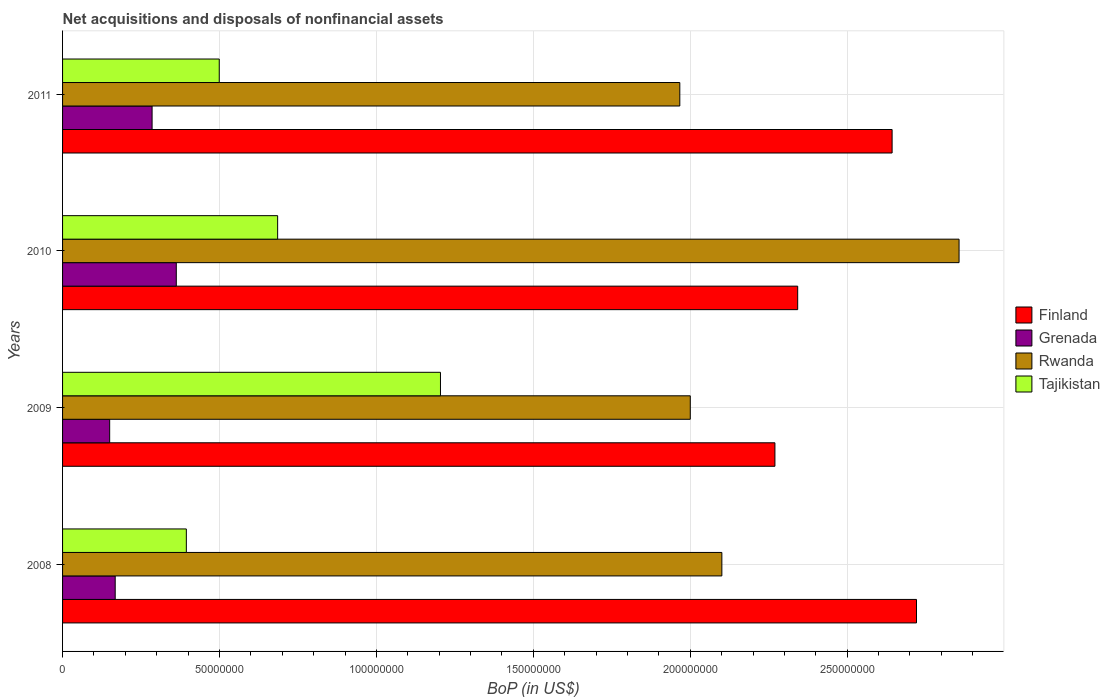Are the number of bars per tick equal to the number of legend labels?
Provide a succinct answer. Yes. Are the number of bars on each tick of the Y-axis equal?
Offer a terse response. Yes. In how many cases, is the number of bars for a given year not equal to the number of legend labels?
Your response must be concise. 0. What is the Balance of Payments in Finland in 2008?
Keep it short and to the point. 2.72e+08. Across all years, what is the maximum Balance of Payments in Tajikistan?
Ensure brevity in your answer.  1.20e+08. Across all years, what is the minimum Balance of Payments in Tajikistan?
Offer a terse response. 3.94e+07. What is the total Balance of Payments in Finland in the graph?
Your response must be concise. 9.98e+08. What is the difference between the Balance of Payments in Grenada in 2008 and that in 2009?
Offer a terse response. 1.76e+06. What is the difference between the Balance of Payments in Finland in 2010 and the Balance of Payments in Tajikistan in 2009?
Offer a very short reply. 1.14e+08. What is the average Balance of Payments in Grenada per year?
Your answer should be compact. 2.41e+07. In the year 2010, what is the difference between the Balance of Payments in Grenada and Balance of Payments in Finland?
Keep it short and to the point. -1.98e+08. In how many years, is the Balance of Payments in Rwanda greater than 220000000 US$?
Your answer should be compact. 1. What is the ratio of the Balance of Payments in Rwanda in 2010 to that in 2011?
Your answer should be compact. 1.45. Is the Balance of Payments in Finland in 2009 less than that in 2011?
Your response must be concise. Yes. Is the difference between the Balance of Payments in Grenada in 2010 and 2011 greater than the difference between the Balance of Payments in Finland in 2010 and 2011?
Give a very brief answer. Yes. What is the difference between the highest and the second highest Balance of Payments in Finland?
Your answer should be very brief. 7.77e+06. What is the difference between the highest and the lowest Balance of Payments in Rwanda?
Ensure brevity in your answer.  8.90e+07. In how many years, is the Balance of Payments in Tajikistan greater than the average Balance of Payments in Tajikistan taken over all years?
Ensure brevity in your answer.  1. What does the 1st bar from the top in 2010 represents?
Provide a short and direct response. Tajikistan. What does the 1st bar from the bottom in 2009 represents?
Keep it short and to the point. Finland. Is it the case that in every year, the sum of the Balance of Payments in Finland and Balance of Payments in Grenada is greater than the Balance of Payments in Tajikistan?
Your answer should be very brief. Yes. How many years are there in the graph?
Your response must be concise. 4. What is the difference between two consecutive major ticks on the X-axis?
Your answer should be compact. 5.00e+07. Are the values on the major ticks of X-axis written in scientific E-notation?
Your response must be concise. No. Where does the legend appear in the graph?
Make the answer very short. Center right. How many legend labels are there?
Provide a succinct answer. 4. What is the title of the graph?
Make the answer very short. Net acquisitions and disposals of nonfinancial assets. What is the label or title of the X-axis?
Provide a succinct answer. BoP (in US$). What is the label or title of the Y-axis?
Your answer should be very brief. Years. What is the BoP (in US$) of Finland in 2008?
Provide a succinct answer. 2.72e+08. What is the BoP (in US$) in Grenada in 2008?
Make the answer very short. 1.68e+07. What is the BoP (in US$) of Rwanda in 2008?
Keep it short and to the point. 2.10e+08. What is the BoP (in US$) in Tajikistan in 2008?
Your answer should be compact. 3.94e+07. What is the BoP (in US$) of Finland in 2009?
Give a very brief answer. 2.27e+08. What is the BoP (in US$) in Grenada in 2009?
Ensure brevity in your answer.  1.50e+07. What is the BoP (in US$) in Rwanda in 2009?
Ensure brevity in your answer.  2.00e+08. What is the BoP (in US$) in Tajikistan in 2009?
Ensure brevity in your answer.  1.20e+08. What is the BoP (in US$) of Finland in 2010?
Your answer should be compact. 2.34e+08. What is the BoP (in US$) in Grenada in 2010?
Keep it short and to the point. 3.62e+07. What is the BoP (in US$) of Rwanda in 2010?
Your answer should be very brief. 2.86e+08. What is the BoP (in US$) of Tajikistan in 2010?
Offer a very short reply. 6.85e+07. What is the BoP (in US$) of Finland in 2011?
Make the answer very short. 2.64e+08. What is the BoP (in US$) in Grenada in 2011?
Provide a succinct answer. 2.85e+07. What is the BoP (in US$) in Rwanda in 2011?
Provide a short and direct response. 1.97e+08. What is the BoP (in US$) in Tajikistan in 2011?
Keep it short and to the point. 4.99e+07. Across all years, what is the maximum BoP (in US$) in Finland?
Provide a succinct answer. 2.72e+08. Across all years, what is the maximum BoP (in US$) in Grenada?
Offer a very short reply. 3.62e+07. Across all years, what is the maximum BoP (in US$) of Rwanda?
Provide a succinct answer. 2.86e+08. Across all years, what is the maximum BoP (in US$) in Tajikistan?
Offer a terse response. 1.20e+08. Across all years, what is the minimum BoP (in US$) of Finland?
Keep it short and to the point. 2.27e+08. Across all years, what is the minimum BoP (in US$) in Grenada?
Your answer should be compact. 1.50e+07. Across all years, what is the minimum BoP (in US$) in Rwanda?
Offer a very short reply. 1.97e+08. Across all years, what is the minimum BoP (in US$) of Tajikistan?
Your response must be concise. 3.94e+07. What is the total BoP (in US$) of Finland in the graph?
Offer a very short reply. 9.98e+08. What is the total BoP (in US$) of Grenada in the graph?
Offer a very short reply. 9.65e+07. What is the total BoP (in US$) in Rwanda in the graph?
Keep it short and to the point. 8.92e+08. What is the total BoP (in US$) of Tajikistan in the graph?
Keep it short and to the point. 2.78e+08. What is the difference between the BoP (in US$) of Finland in 2008 and that in 2009?
Offer a very short reply. 4.51e+07. What is the difference between the BoP (in US$) of Grenada in 2008 and that in 2009?
Give a very brief answer. 1.76e+06. What is the difference between the BoP (in US$) in Rwanda in 2008 and that in 2009?
Offer a terse response. 1.01e+07. What is the difference between the BoP (in US$) in Tajikistan in 2008 and that in 2009?
Your response must be concise. -8.10e+07. What is the difference between the BoP (in US$) of Finland in 2008 and that in 2010?
Your response must be concise. 3.79e+07. What is the difference between the BoP (in US$) in Grenada in 2008 and that in 2010?
Your answer should be very brief. -1.95e+07. What is the difference between the BoP (in US$) in Rwanda in 2008 and that in 2010?
Offer a terse response. -7.56e+07. What is the difference between the BoP (in US$) of Tajikistan in 2008 and that in 2010?
Make the answer very short. -2.91e+07. What is the difference between the BoP (in US$) of Finland in 2008 and that in 2011?
Keep it short and to the point. 7.77e+06. What is the difference between the BoP (in US$) in Grenada in 2008 and that in 2011?
Give a very brief answer. -1.18e+07. What is the difference between the BoP (in US$) in Rwanda in 2008 and that in 2011?
Provide a short and direct response. 1.34e+07. What is the difference between the BoP (in US$) of Tajikistan in 2008 and that in 2011?
Your answer should be very brief. -1.05e+07. What is the difference between the BoP (in US$) of Finland in 2009 and that in 2010?
Offer a very short reply. -7.25e+06. What is the difference between the BoP (in US$) of Grenada in 2009 and that in 2010?
Your response must be concise. -2.12e+07. What is the difference between the BoP (in US$) in Rwanda in 2009 and that in 2010?
Ensure brevity in your answer.  -8.56e+07. What is the difference between the BoP (in US$) in Tajikistan in 2009 and that in 2010?
Your response must be concise. 5.19e+07. What is the difference between the BoP (in US$) in Finland in 2009 and that in 2011?
Make the answer very short. -3.73e+07. What is the difference between the BoP (in US$) in Grenada in 2009 and that in 2011?
Keep it short and to the point. -1.35e+07. What is the difference between the BoP (in US$) in Rwanda in 2009 and that in 2011?
Offer a very short reply. 3.34e+06. What is the difference between the BoP (in US$) in Tajikistan in 2009 and that in 2011?
Give a very brief answer. 7.05e+07. What is the difference between the BoP (in US$) in Finland in 2010 and that in 2011?
Your response must be concise. -3.01e+07. What is the difference between the BoP (in US$) of Grenada in 2010 and that in 2011?
Your answer should be very brief. 7.71e+06. What is the difference between the BoP (in US$) of Rwanda in 2010 and that in 2011?
Offer a very short reply. 8.90e+07. What is the difference between the BoP (in US$) of Tajikistan in 2010 and that in 2011?
Keep it short and to the point. 1.86e+07. What is the difference between the BoP (in US$) in Finland in 2008 and the BoP (in US$) in Grenada in 2009?
Provide a short and direct response. 2.57e+08. What is the difference between the BoP (in US$) in Finland in 2008 and the BoP (in US$) in Rwanda in 2009?
Your response must be concise. 7.21e+07. What is the difference between the BoP (in US$) in Finland in 2008 and the BoP (in US$) in Tajikistan in 2009?
Your answer should be compact. 1.52e+08. What is the difference between the BoP (in US$) in Grenada in 2008 and the BoP (in US$) in Rwanda in 2009?
Ensure brevity in your answer.  -1.83e+08. What is the difference between the BoP (in US$) in Grenada in 2008 and the BoP (in US$) in Tajikistan in 2009?
Keep it short and to the point. -1.04e+08. What is the difference between the BoP (in US$) of Rwanda in 2008 and the BoP (in US$) of Tajikistan in 2009?
Provide a short and direct response. 8.97e+07. What is the difference between the BoP (in US$) in Finland in 2008 and the BoP (in US$) in Grenada in 2010?
Give a very brief answer. 2.36e+08. What is the difference between the BoP (in US$) of Finland in 2008 and the BoP (in US$) of Rwanda in 2010?
Offer a very short reply. -1.36e+07. What is the difference between the BoP (in US$) of Finland in 2008 and the BoP (in US$) of Tajikistan in 2010?
Offer a terse response. 2.04e+08. What is the difference between the BoP (in US$) of Grenada in 2008 and the BoP (in US$) of Rwanda in 2010?
Your answer should be compact. -2.69e+08. What is the difference between the BoP (in US$) in Grenada in 2008 and the BoP (in US$) in Tajikistan in 2010?
Provide a succinct answer. -5.18e+07. What is the difference between the BoP (in US$) of Rwanda in 2008 and the BoP (in US$) of Tajikistan in 2010?
Give a very brief answer. 1.42e+08. What is the difference between the BoP (in US$) in Finland in 2008 and the BoP (in US$) in Grenada in 2011?
Keep it short and to the point. 2.44e+08. What is the difference between the BoP (in US$) of Finland in 2008 and the BoP (in US$) of Rwanda in 2011?
Offer a very short reply. 7.54e+07. What is the difference between the BoP (in US$) in Finland in 2008 and the BoP (in US$) in Tajikistan in 2011?
Keep it short and to the point. 2.22e+08. What is the difference between the BoP (in US$) in Grenada in 2008 and the BoP (in US$) in Rwanda in 2011?
Your answer should be very brief. -1.80e+08. What is the difference between the BoP (in US$) in Grenada in 2008 and the BoP (in US$) in Tajikistan in 2011?
Your answer should be compact. -3.32e+07. What is the difference between the BoP (in US$) of Rwanda in 2008 and the BoP (in US$) of Tajikistan in 2011?
Provide a short and direct response. 1.60e+08. What is the difference between the BoP (in US$) of Finland in 2009 and the BoP (in US$) of Grenada in 2010?
Offer a terse response. 1.91e+08. What is the difference between the BoP (in US$) of Finland in 2009 and the BoP (in US$) of Rwanda in 2010?
Offer a very short reply. -5.87e+07. What is the difference between the BoP (in US$) of Finland in 2009 and the BoP (in US$) of Tajikistan in 2010?
Your answer should be very brief. 1.58e+08. What is the difference between the BoP (in US$) in Grenada in 2009 and the BoP (in US$) in Rwanda in 2010?
Provide a short and direct response. -2.71e+08. What is the difference between the BoP (in US$) of Grenada in 2009 and the BoP (in US$) of Tajikistan in 2010?
Offer a terse response. -5.35e+07. What is the difference between the BoP (in US$) of Rwanda in 2009 and the BoP (in US$) of Tajikistan in 2010?
Your response must be concise. 1.31e+08. What is the difference between the BoP (in US$) in Finland in 2009 and the BoP (in US$) in Grenada in 2011?
Provide a succinct answer. 1.98e+08. What is the difference between the BoP (in US$) of Finland in 2009 and the BoP (in US$) of Rwanda in 2011?
Provide a succinct answer. 3.03e+07. What is the difference between the BoP (in US$) in Finland in 2009 and the BoP (in US$) in Tajikistan in 2011?
Make the answer very short. 1.77e+08. What is the difference between the BoP (in US$) of Grenada in 2009 and the BoP (in US$) of Rwanda in 2011?
Ensure brevity in your answer.  -1.82e+08. What is the difference between the BoP (in US$) in Grenada in 2009 and the BoP (in US$) in Tajikistan in 2011?
Your answer should be very brief. -3.49e+07. What is the difference between the BoP (in US$) in Rwanda in 2009 and the BoP (in US$) in Tajikistan in 2011?
Your answer should be very brief. 1.50e+08. What is the difference between the BoP (in US$) in Finland in 2010 and the BoP (in US$) in Grenada in 2011?
Provide a short and direct response. 2.06e+08. What is the difference between the BoP (in US$) in Finland in 2010 and the BoP (in US$) in Rwanda in 2011?
Provide a succinct answer. 3.76e+07. What is the difference between the BoP (in US$) in Finland in 2010 and the BoP (in US$) in Tajikistan in 2011?
Your answer should be very brief. 1.84e+08. What is the difference between the BoP (in US$) in Grenada in 2010 and the BoP (in US$) in Rwanda in 2011?
Make the answer very short. -1.60e+08. What is the difference between the BoP (in US$) of Grenada in 2010 and the BoP (in US$) of Tajikistan in 2011?
Make the answer very short. -1.37e+07. What is the difference between the BoP (in US$) in Rwanda in 2010 and the BoP (in US$) in Tajikistan in 2011?
Ensure brevity in your answer.  2.36e+08. What is the average BoP (in US$) of Finland per year?
Give a very brief answer. 2.49e+08. What is the average BoP (in US$) in Grenada per year?
Keep it short and to the point. 2.41e+07. What is the average BoP (in US$) in Rwanda per year?
Your response must be concise. 2.23e+08. What is the average BoP (in US$) of Tajikistan per year?
Your response must be concise. 6.96e+07. In the year 2008, what is the difference between the BoP (in US$) in Finland and BoP (in US$) in Grenada?
Offer a terse response. 2.55e+08. In the year 2008, what is the difference between the BoP (in US$) of Finland and BoP (in US$) of Rwanda?
Make the answer very short. 6.20e+07. In the year 2008, what is the difference between the BoP (in US$) in Finland and BoP (in US$) in Tajikistan?
Provide a short and direct response. 2.33e+08. In the year 2008, what is the difference between the BoP (in US$) in Grenada and BoP (in US$) in Rwanda?
Provide a short and direct response. -1.93e+08. In the year 2008, what is the difference between the BoP (in US$) of Grenada and BoP (in US$) of Tajikistan?
Your response must be concise. -2.27e+07. In the year 2008, what is the difference between the BoP (in US$) in Rwanda and BoP (in US$) in Tajikistan?
Provide a short and direct response. 1.71e+08. In the year 2009, what is the difference between the BoP (in US$) in Finland and BoP (in US$) in Grenada?
Ensure brevity in your answer.  2.12e+08. In the year 2009, what is the difference between the BoP (in US$) of Finland and BoP (in US$) of Rwanda?
Your answer should be very brief. 2.70e+07. In the year 2009, what is the difference between the BoP (in US$) of Finland and BoP (in US$) of Tajikistan?
Offer a terse response. 1.07e+08. In the year 2009, what is the difference between the BoP (in US$) of Grenada and BoP (in US$) of Rwanda?
Provide a succinct answer. -1.85e+08. In the year 2009, what is the difference between the BoP (in US$) in Grenada and BoP (in US$) in Tajikistan?
Ensure brevity in your answer.  -1.05e+08. In the year 2009, what is the difference between the BoP (in US$) in Rwanda and BoP (in US$) in Tajikistan?
Offer a very short reply. 7.96e+07. In the year 2010, what is the difference between the BoP (in US$) in Finland and BoP (in US$) in Grenada?
Offer a very short reply. 1.98e+08. In the year 2010, what is the difference between the BoP (in US$) in Finland and BoP (in US$) in Rwanda?
Make the answer very short. -5.14e+07. In the year 2010, what is the difference between the BoP (in US$) in Finland and BoP (in US$) in Tajikistan?
Give a very brief answer. 1.66e+08. In the year 2010, what is the difference between the BoP (in US$) of Grenada and BoP (in US$) of Rwanda?
Give a very brief answer. -2.49e+08. In the year 2010, what is the difference between the BoP (in US$) of Grenada and BoP (in US$) of Tajikistan?
Your answer should be compact. -3.23e+07. In the year 2010, what is the difference between the BoP (in US$) of Rwanda and BoP (in US$) of Tajikistan?
Offer a very short reply. 2.17e+08. In the year 2011, what is the difference between the BoP (in US$) in Finland and BoP (in US$) in Grenada?
Provide a short and direct response. 2.36e+08. In the year 2011, what is the difference between the BoP (in US$) of Finland and BoP (in US$) of Rwanda?
Offer a terse response. 6.76e+07. In the year 2011, what is the difference between the BoP (in US$) in Finland and BoP (in US$) in Tajikistan?
Keep it short and to the point. 2.14e+08. In the year 2011, what is the difference between the BoP (in US$) in Grenada and BoP (in US$) in Rwanda?
Ensure brevity in your answer.  -1.68e+08. In the year 2011, what is the difference between the BoP (in US$) in Grenada and BoP (in US$) in Tajikistan?
Offer a very short reply. -2.14e+07. In the year 2011, what is the difference between the BoP (in US$) of Rwanda and BoP (in US$) of Tajikistan?
Make the answer very short. 1.47e+08. What is the ratio of the BoP (in US$) of Finland in 2008 to that in 2009?
Provide a short and direct response. 1.2. What is the ratio of the BoP (in US$) of Grenada in 2008 to that in 2009?
Ensure brevity in your answer.  1.12. What is the ratio of the BoP (in US$) in Rwanda in 2008 to that in 2009?
Keep it short and to the point. 1.05. What is the ratio of the BoP (in US$) in Tajikistan in 2008 to that in 2009?
Offer a very short reply. 0.33. What is the ratio of the BoP (in US$) of Finland in 2008 to that in 2010?
Offer a very short reply. 1.16. What is the ratio of the BoP (in US$) in Grenada in 2008 to that in 2010?
Keep it short and to the point. 0.46. What is the ratio of the BoP (in US$) in Rwanda in 2008 to that in 2010?
Offer a terse response. 0.74. What is the ratio of the BoP (in US$) in Tajikistan in 2008 to that in 2010?
Your answer should be compact. 0.58. What is the ratio of the BoP (in US$) in Finland in 2008 to that in 2011?
Offer a terse response. 1.03. What is the ratio of the BoP (in US$) of Grenada in 2008 to that in 2011?
Your answer should be compact. 0.59. What is the ratio of the BoP (in US$) in Rwanda in 2008 to that in 2011?
Your answer should be very brief. 1.07. What is the ratio of the BoP (in US$) of Tajikistan in 2008 to that in 2011?
Make the answer very short. 0.79. What is the ratio of the BoP (in US$) of Finland in 2009 to that in 2010?
Your response must be concise. 0.97. What is the ratio of the BoP (in US$) of Grenada in 2009 to that in 2010?
Keep it short and to the point. 0.41. What is the ratio of the BoP (in US$) of Rwanda in 2009 to that in 2010?
Provide a short and direct response. 0.7. What is the ratio of the BoP (in US$) of Tajikistan in 2009 to that in 2010?
Your response must be concise. 1.76. What is the ratio of the BoP (in US$) of Finland in 2009 to that in 2011?
Your answer should be compact. 0.86. What is the ratio of the BoP (in US$) of Grenada in 2009 to that in 2011?
Provide a succinct answer. 0.53. What is the ratio of the BoP (in US$) of Tajikistan in 2009 to that in 2011?
Your response must be concise. 2.41. What is the ratio of the BoP (in US$) in Finland in 2010 to that in 2011?
Ensure brevity in your answer.  0.89. What is the ratio of the BoP (in US$) in Grenada in 2010 to that in 2011?
Provide a short and direct response. 1.27. What is the ratio of the BoP (in US$) in Rwanda in 2010 to that in 2011?
Provide a succinct answer. 1.45. What is the ratio of the BoP (in US$) in Tajikistan in 2010 to that in 2011?
Your answer should be compact. 1.37. What is the difference between the highest and the second highest BoP (in US$) in Finland?
Provide a succinct answer. 7.77e+06. What is the difference between the highest and the second highest BoP (in US$) of Grenada?
Make the answer very short. 7.71e+06. What is the difference between the highest and the second highest BoP (in US$) of Rwanda?
Give a very brief answer. 7.56e+07. What is the difference between the highest and the second highest BoP (in US$) in Tajikistan?
Your response must be concise. 5.19e+07. What is the difference between the highest and the lowest BoP (in US$) in Finland?
Offer a very short reply. 4.51e+07. What is the difference between the highest and the lowest BoP (in US$) in Grenada?
Offer a terse response. 2.12e+07. What is the difference between the highest and the lowest BoP (in US$) in Rwanda?
Offer a very short reply. 8.90e+07. What is the difference between the highest and the lowest BoP (in US$) of Tajikistan?
Give a very brief answer. 8.10e+07. 